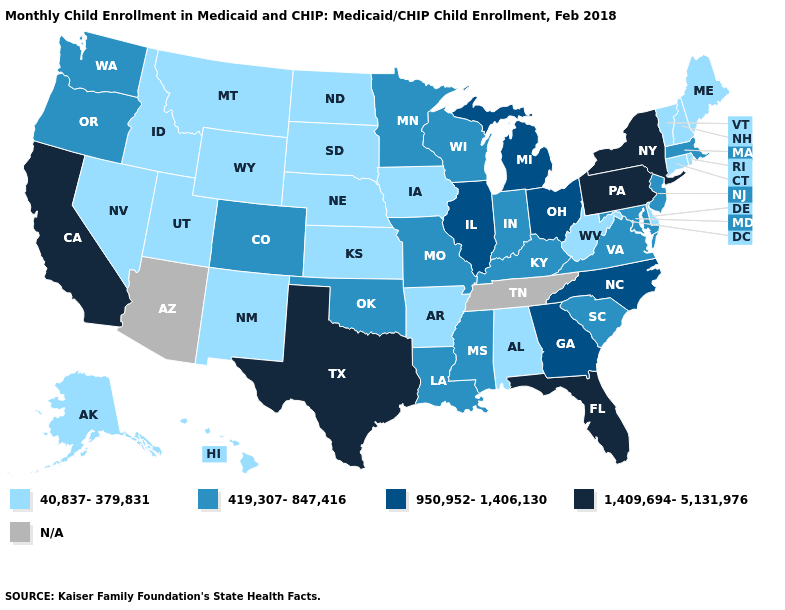Name the states that have a value in the range 1,409,694-5,131,976?
Concise answer only. California, Florida, New York, Pennsylvania, Texas. What is the lowest value in the USA?
Concise answer only. 40,837-379,831. What is the value of Alaska?
Give a very brief answer. 40,837-379,831. Among the states that border Pennsylvania , does New Jersey have the highest value?
Be succinct. No. Among the states that border Texas , does Louisiana have the lowest value?
Answer briefly. No. Does the first symbol in the legend represent the smallest category?
Answer briefly. Yes. What is the highest value in states that border North Dakota?
Quick response, please. 419,307-847,416. Name the states that have a value in the range 1,409,694-5,131,976?
Write a very short answer. California, Florida, New York, Pennsylvania, Texas. Name the states that have a value in the range 950,952-1,406,130?
Quick response, please. Georgia, Illinois, Michigan, North Carolina, Ohio. Name the states that have a value in the range 950,952-1,406,130?
Keep it brief. Georgia, Illinois, Michigan, North Carolina, Ohio. What is the lowest value in states that border Maryland?
Short answer required. 40,837-379,831. How many symbols are there in the legend?
Give a very brief answer. 5. What is the value of South Carolina?
Short answer required. 419,307-847,416. 